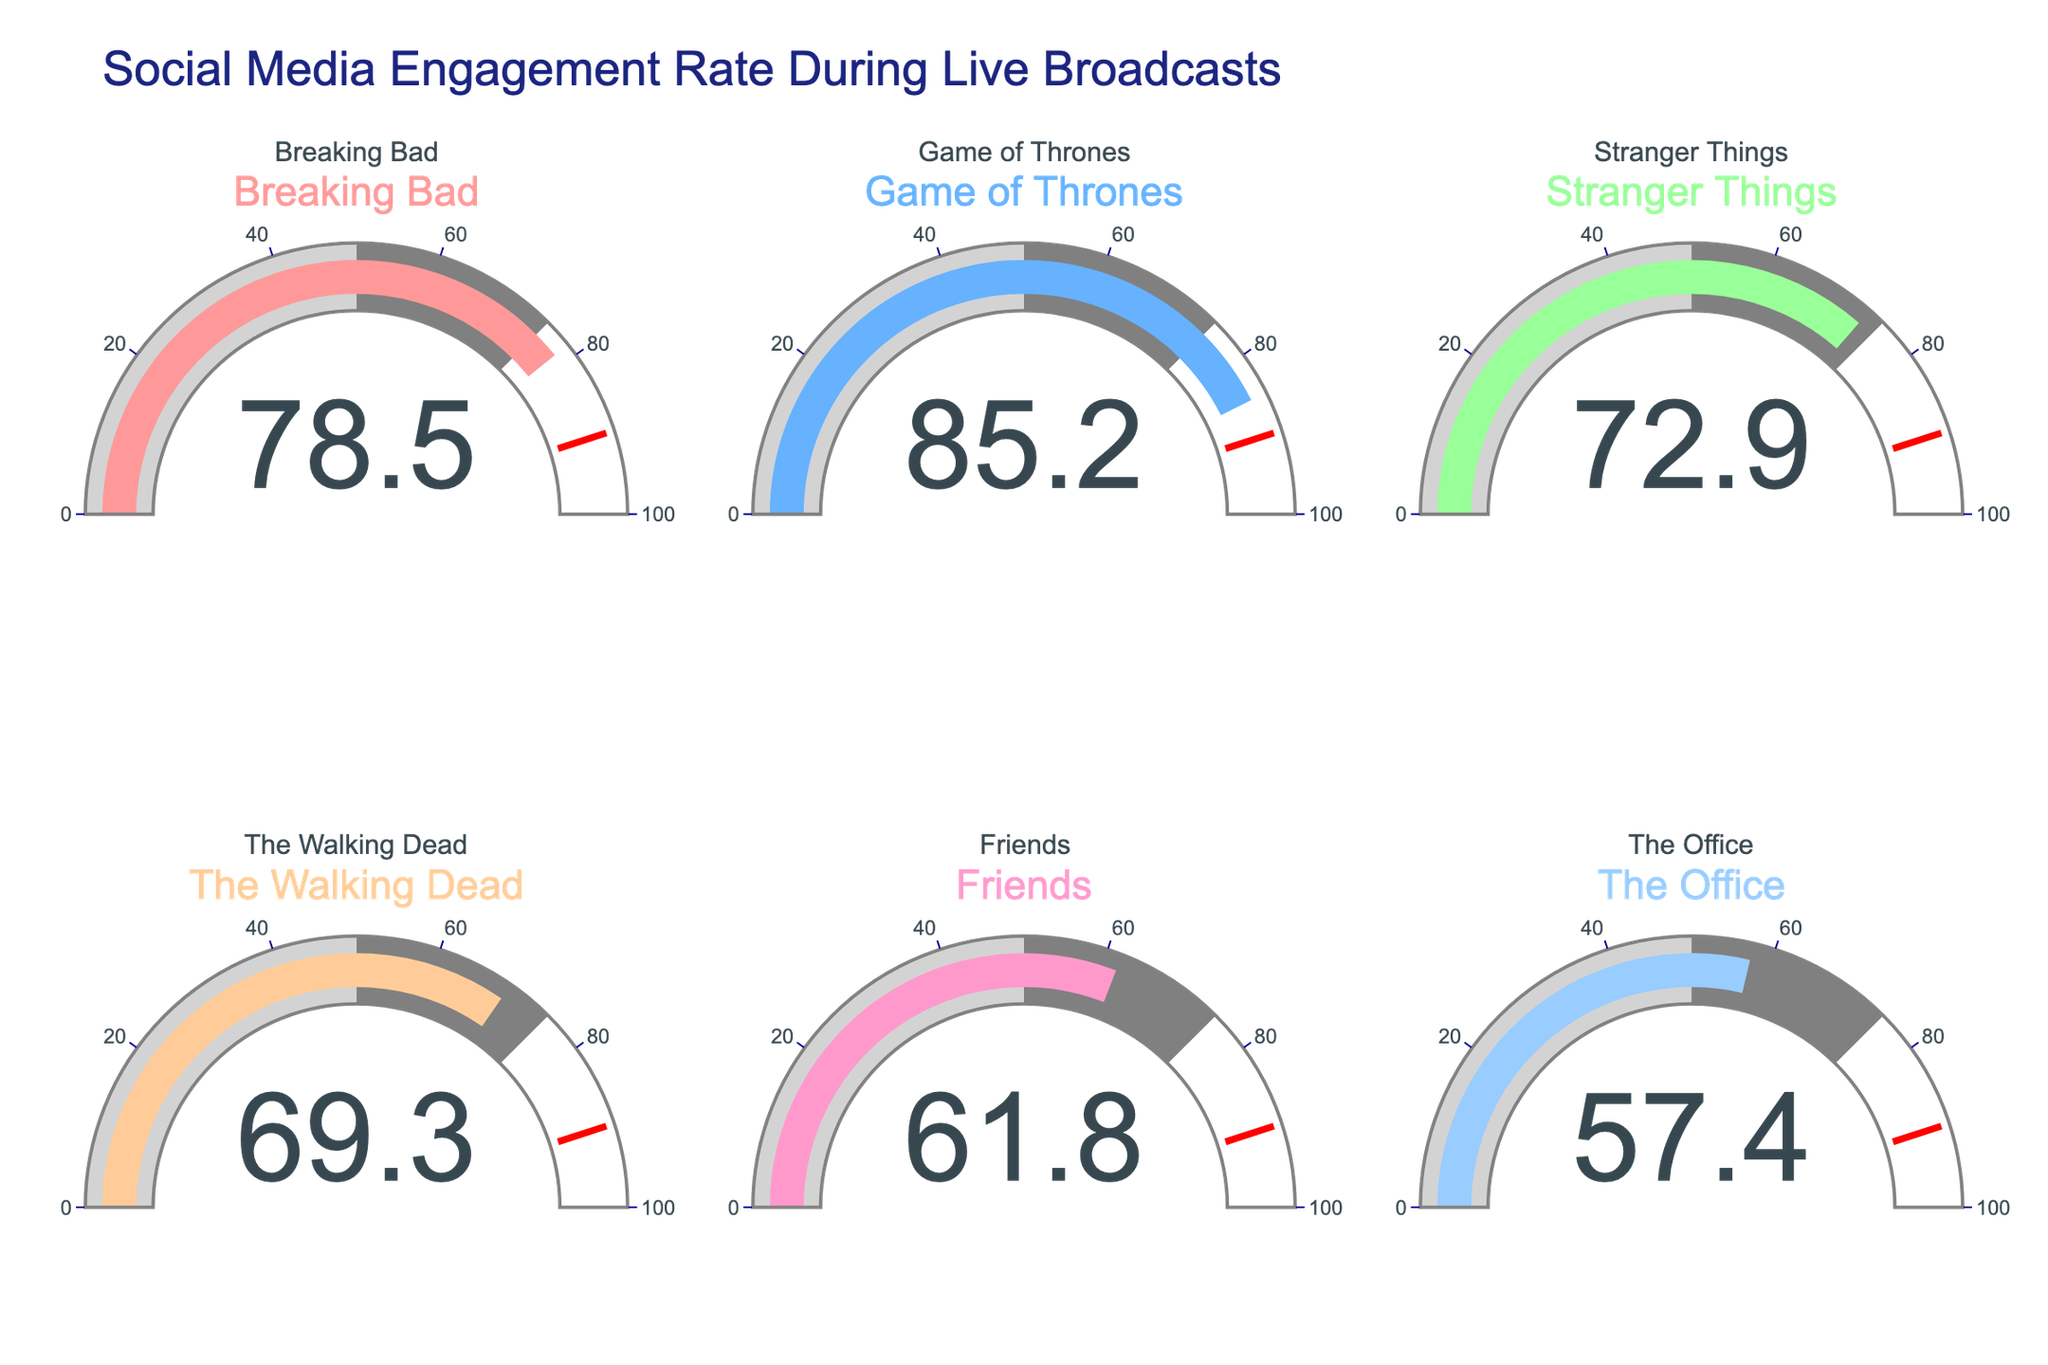what is the engagement rate for Game of Thrones? Look at the gauge labeled "Game of Thrones," its engagement rate is indicated by the number inside the gauge.
Answer: 85.2 Which show has the lowest engagement rate? By examining each gauge and the corresponding numbers, identify the show with the lowest number.
Answer: The Office What is the difference in engagement rate between Breaking Bad and The Walking Dead? The engagement rate for Breaking Bad is 78.5 and for The Walking Dead is 69.3. Subtract 69.3 from 78.5 to find the difference.
Answer: 9.2 How many shows have an engagement rate above 70? Count the number of gauges where the value inside is greater than 70.
Answer: 3 Which show has a higher engagement rate: Stranger Things or Friends? Compare the engagement rate numbers in the gauges for Stranger Things and Friends.
Answer: Stranger Things What is the average engagement rate of all the shows? Add the engagement rates of all the shows and divide by the number of shows (sum: 78.5 + 85.2 + 72.9 + 69.3 + 61.8 + 57.4 = 425.1). There are 6 shows, so the average is 425.1 / 6.
Answer: 70.85 Are any of the shows' engagement rates above the 90 mark on the gauge? Check if any of the gauges have values higher than 90.
Answer: No How does the engagement rate of Breaking Bad compare to the network average (assume the network average is 60)? Compare the engagement rate of Breaking Bad to 60 to determine if it is higher or lower.
Answer: Higher 